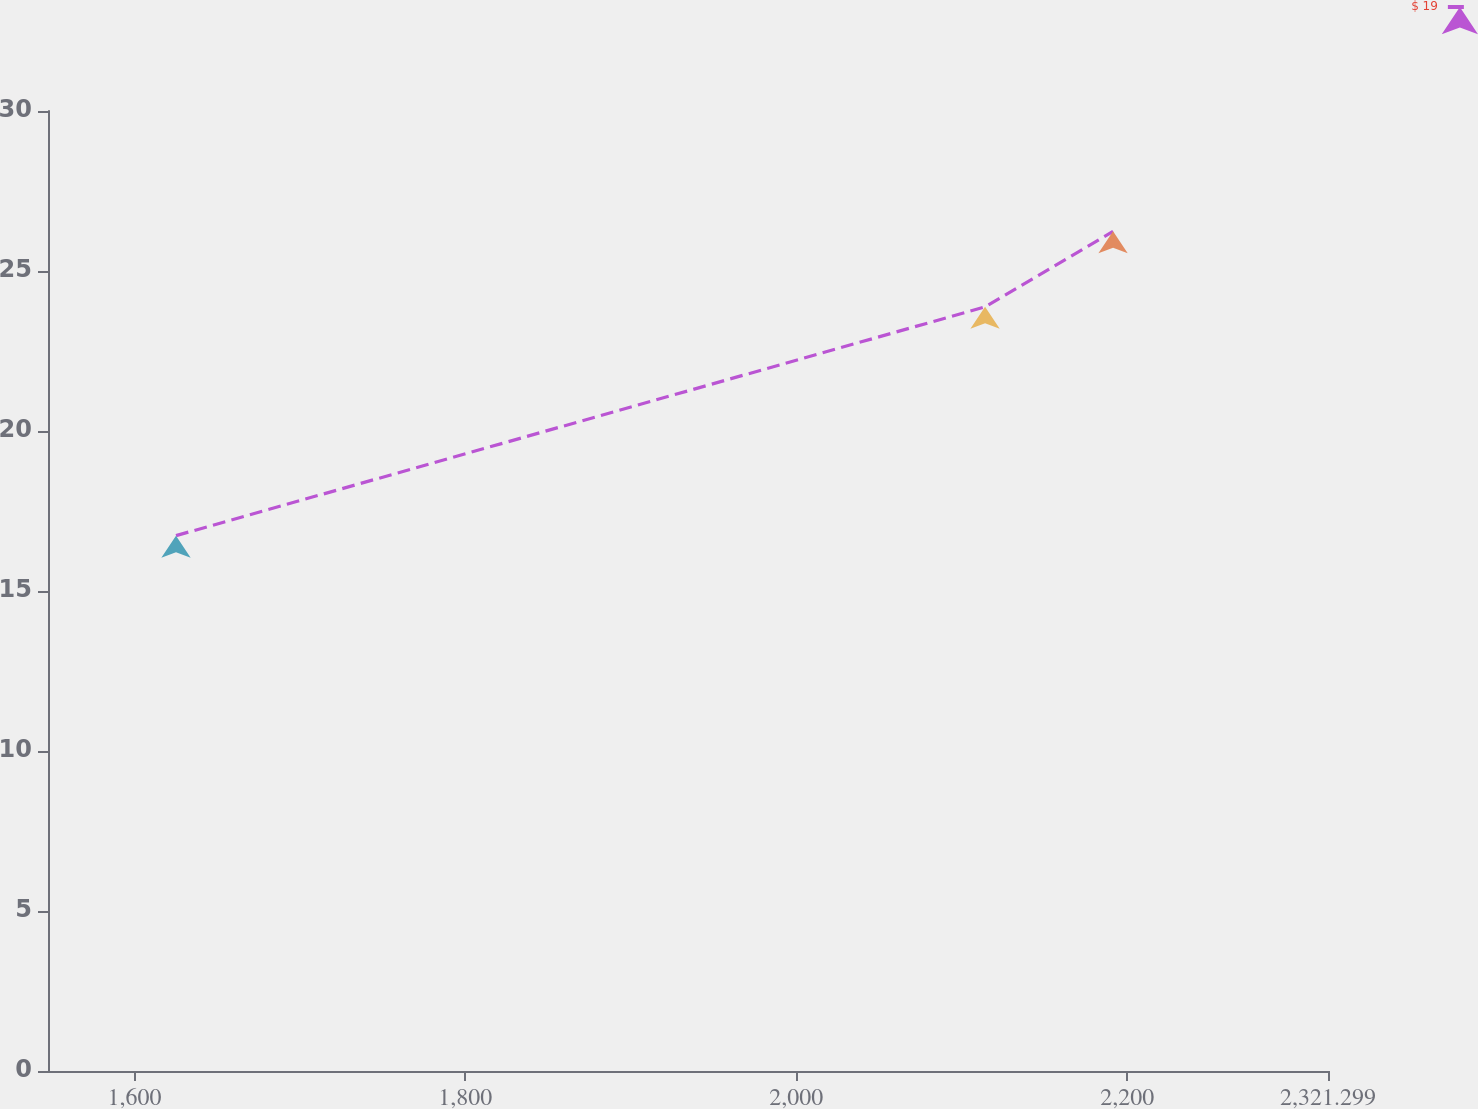<chart> <loc_0><loc_0><loc_500><loc_500><line_chart><ecel><fcel>$ 19<nl><fcel>1625.14<fcel>16.73<nl><fcel>2114.06<fcel>23.88<nl><fcel>2191.41<fcel>26.24<nl><fcel>2398.65<fcel>29.42<nl></chart> 